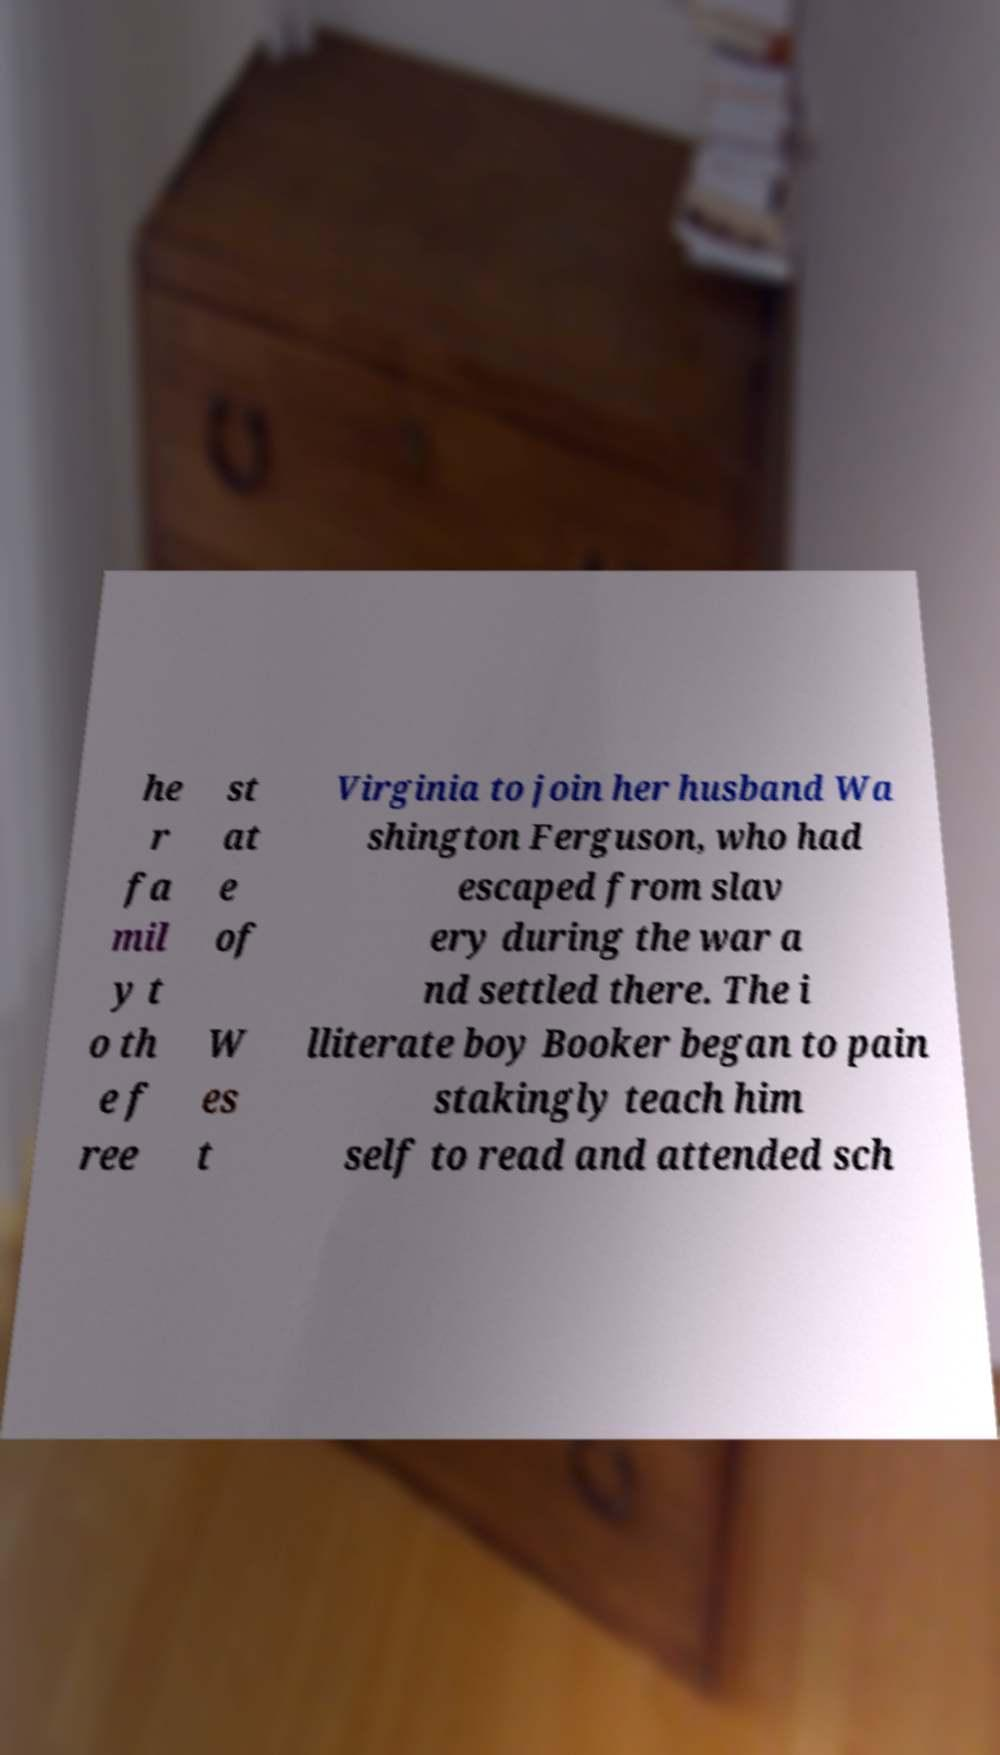There's text embedded in this image that I need extracted. Can you transcribe it verbatim? he r fa mil y t o th e f ree st at e of W es t Virginia to join her husband Wa shington Ferguson, who had escaped from slav ery during the war a nd settled there. The i lliterate boy Booker began to pain stakingly teach him self to read and attended sch 